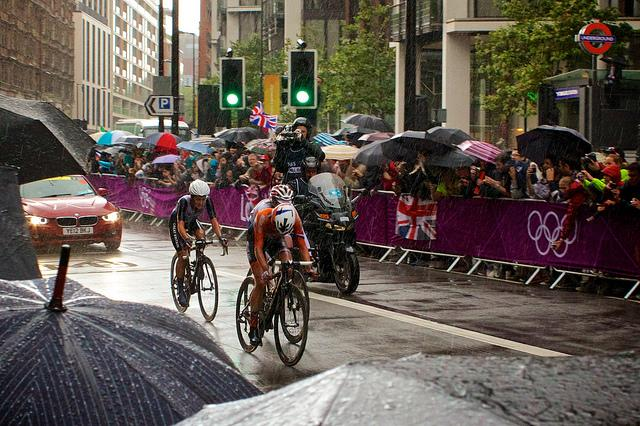When was the Union Jack invented?

Choices:
A) 1606
B) 1612
C) 1672
D) 1619 1606 